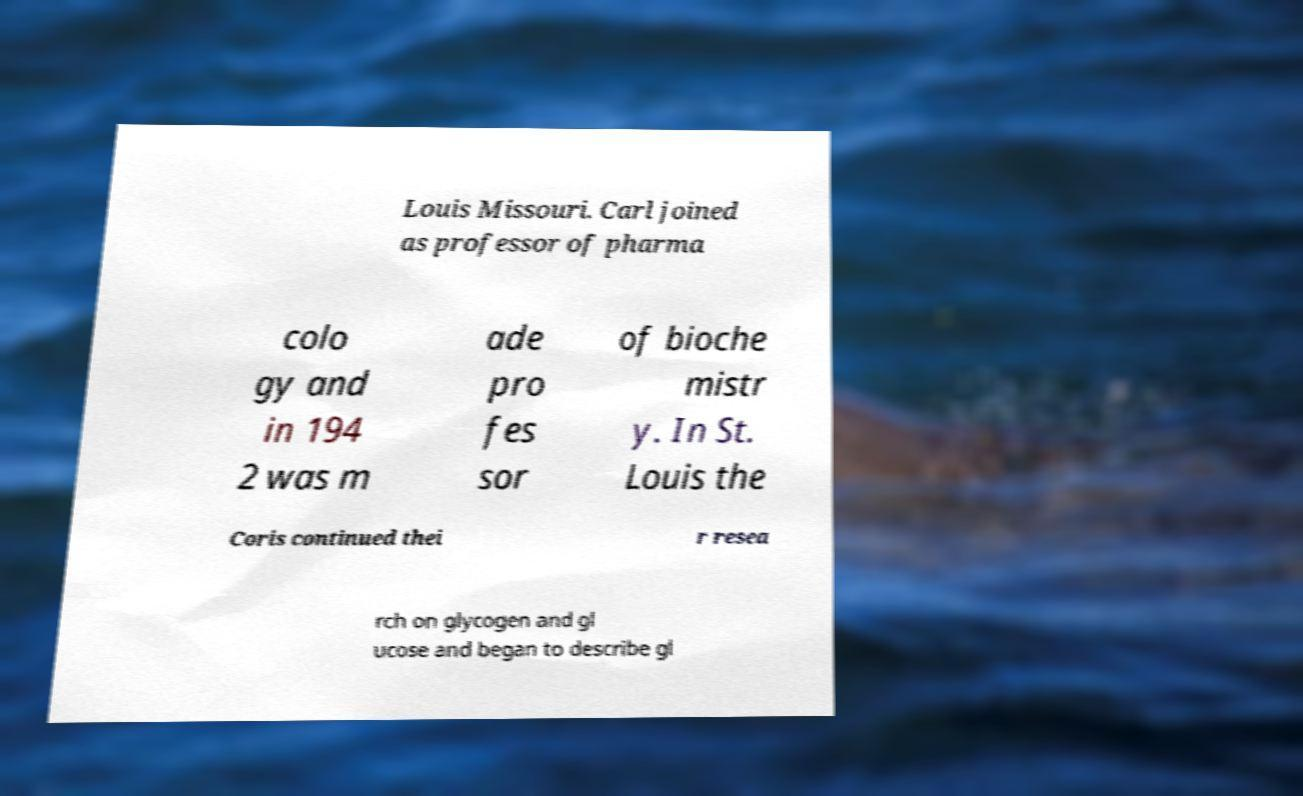Can you read and provide the text displayed in the image?This photo seems to have some interesting text. Can you extract and type it out for me? Louis Missouri. Carl joined as professor of pharma colo gy and in 194 2 was m ade pro fes sor of bioche mistr y. In St. Louis the Coris continued thei r resea rch on glycogen and gl ucose and began to describe gl 